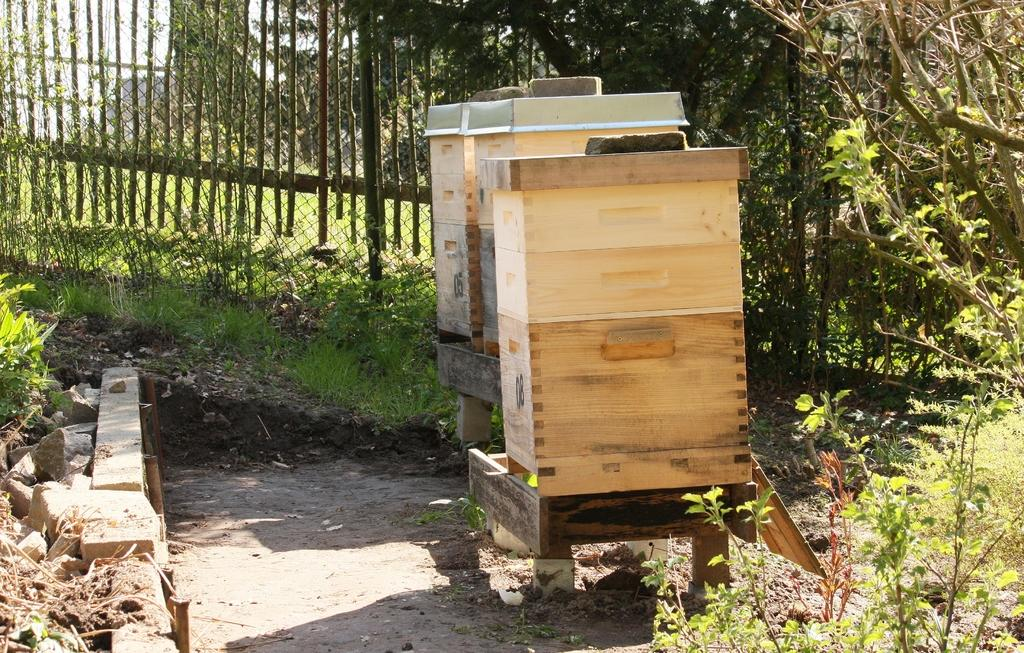What objects are on stands in the image? There are three wooden boxes on stands in the image. What is located near the wooden boxes? There are plants and stones on the ground near the wooden boxes. What can be seen in the background of the image? There is a fence, trees, and the sky visible in the background of the image. What type of ball is being used to act in the image? There is no ball or act present in the image; it features wooden boxes on stands, plants, stones, a fence, trees, and the sky. How many people are visible in the image? There is no person present in the image; it only features wooden boxes, plants, stones, a fence, trees, and the sky. 